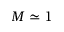Convert formula to latex. <formula><loc_0><loc_0><loc_500><loc_500>M \simeq 1</formula> 